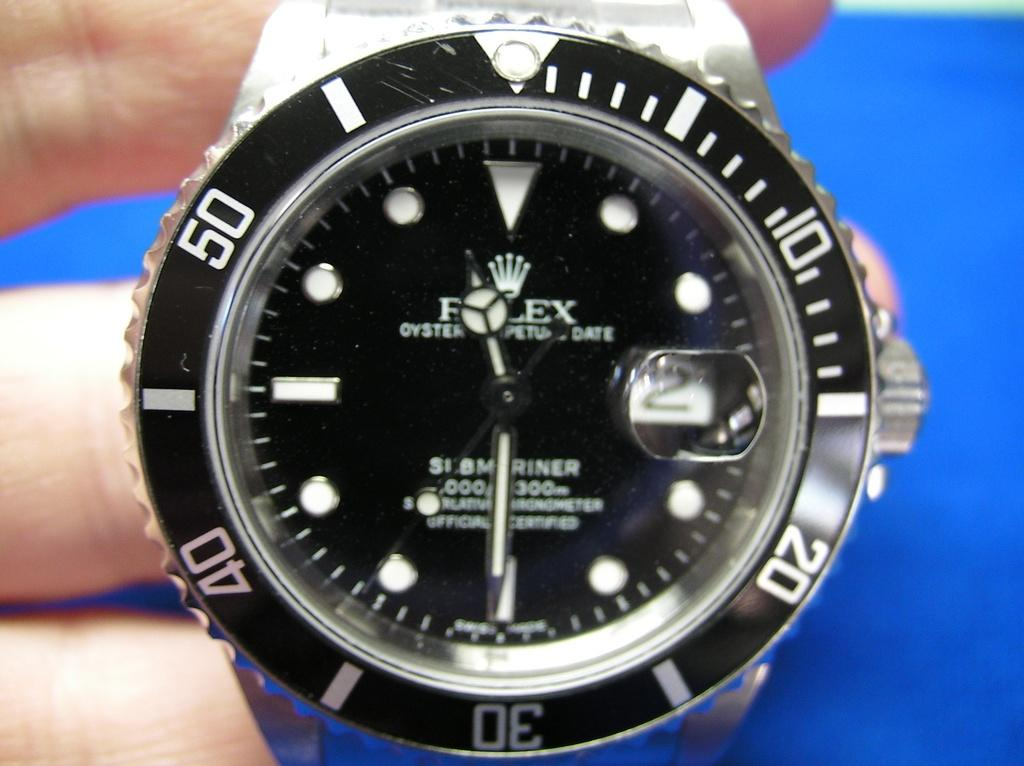<image>
Render a clear and concise summary of the photo. A Rolex watch has a black face with white and silver detailing. 